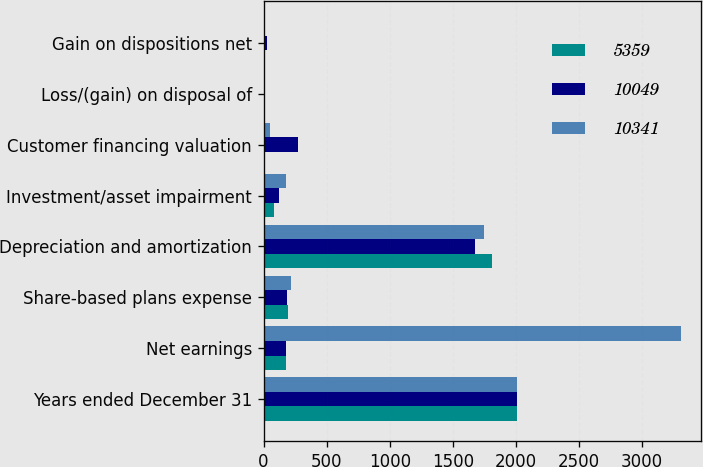Convert chart to OTSL. <chart><loc_0><loc_0><loc_500><loc_500><stacked_bar_chart><ecel><fcel>Years ended December 31<fcel>Net earnings<fcel>Share-based plans expense<fcel>Depreciation and amortization<fcel>Investment/asset impairment<fcel>Customer financing valuation<fcel>Loss/(gain) on disposal of<fcel>Gain on dispositions net<nl><fcel>5359<fcel>2012<fcel>180<fcel>193<fcel>1811<fcel>84<fcel>10<fcel>5<fcel>4<nl><fcel>10049<fcel>2011<fcel>180<fcel>186<fcel>1675<fcel>119<fcel>269<fcel>11<fcel>24<nl><fcel>10341<fcel>2010<fcel>3307<fcel>215<fcel>1746<fcel>174<fcel>51<fcel>6<fcel>6<nl></chart> 